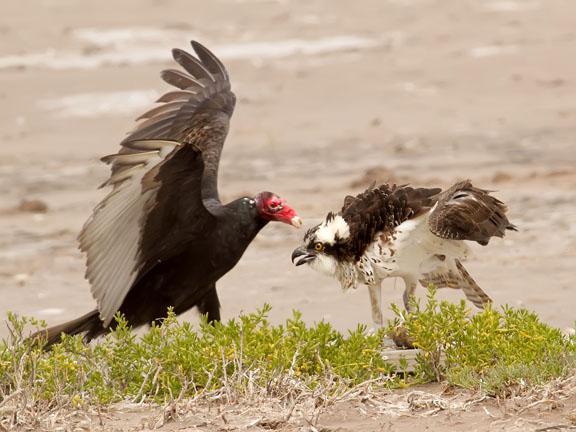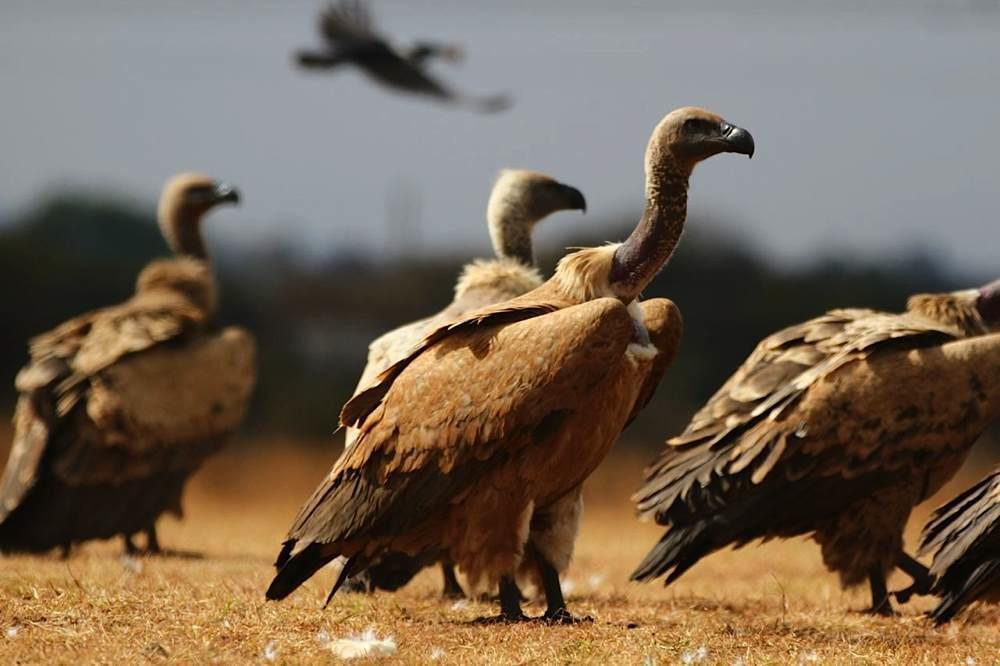The first image is the image on the left, the second image is the image on the right. Evaluate the accuracy of this statement regarding the images: "Right image shows a bird in the foreground with wings spread and off the ground.". Is it true? Answer yes or no. No. The first image is the image on the left, the second image is the image on the right. For the images displayed, is the sentence "One image in the pair includes vultures with a carcass." factually correct? Answer yes or no. No. 